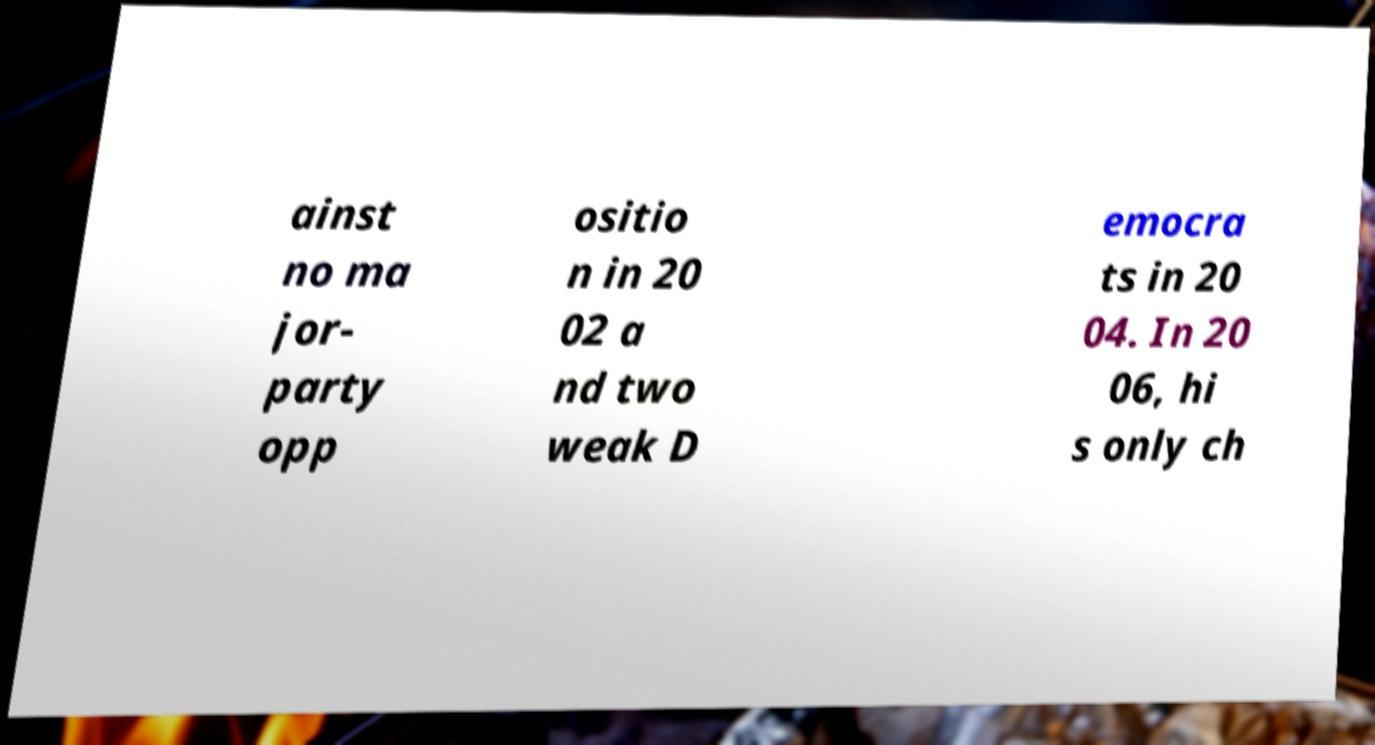Could you assist in decoding the text presented in this image and type it out clearly? ainst no ma jor- party opp ositio n in 20 02 a nd two weak D emocra ts in 20 04. In 20 06, hi s only ch 